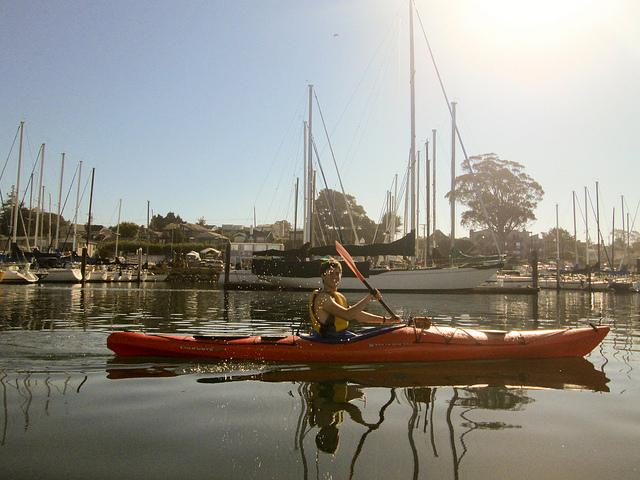What is the person riding in? Please explain your reasoning. canoe. The person is not in a land or air vehicle. the person is above water. 